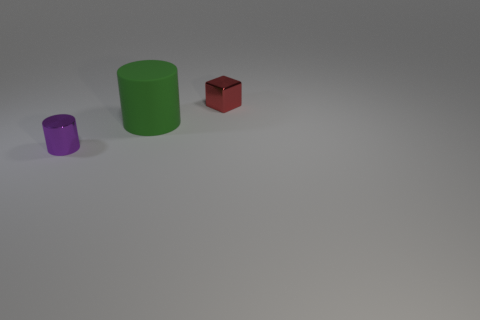Add 1 small purple metal blocks. How many objects exist? 4 Subtract all cubes. How many objects are left? 2 Subtract all cyan cubes. Subtract all gray balls. How many cubes are left? 1 Subtract all big blue metallic balls. Subtract all matte objects. How many objects are left? 2 Add 1 small metal cubes. How many small metal cubes are left? 2 Add 3 metal cylinders. How many metal cylinders exist? 4 Subtract 0 gray blocks. How many objects are left? 3 